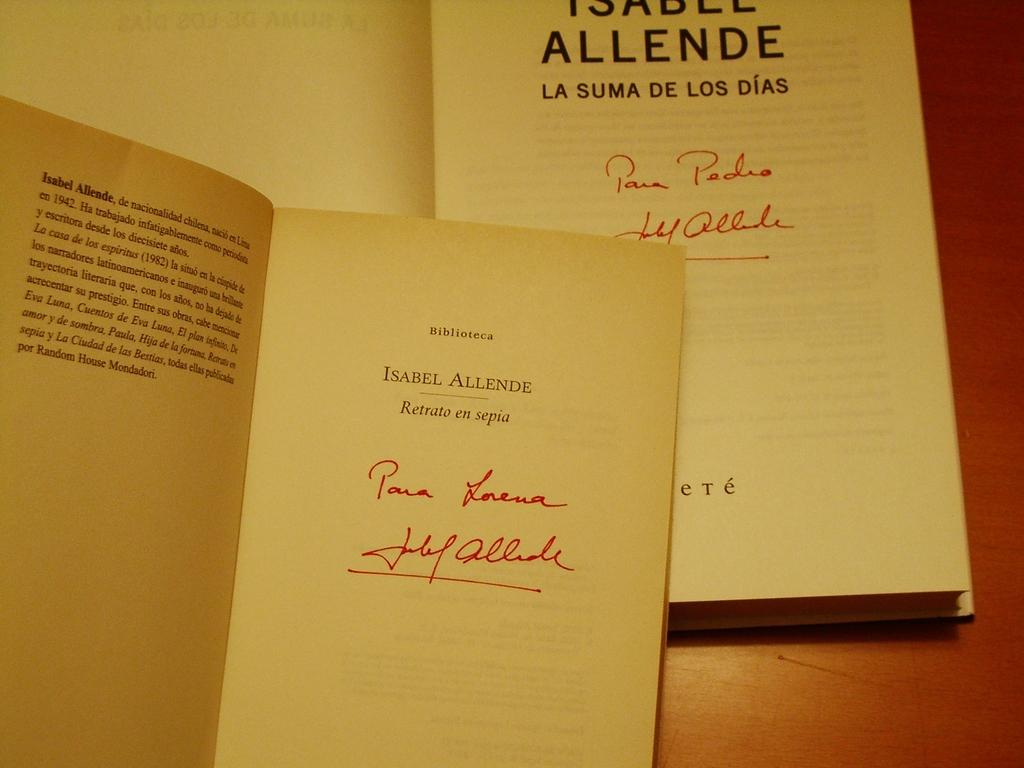<image>
Present a compact description of the photo's key features. A copy of the book Isabel Allende is autographed in red pen. 